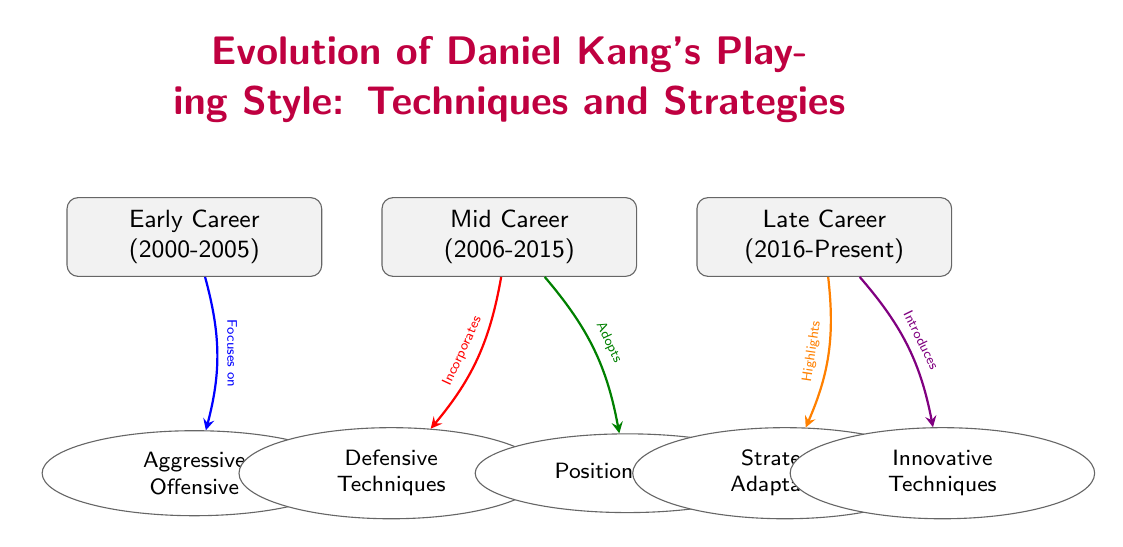What are the three career stages depicted in the diagram? The diagram lists three distinct career stages for Daniel Kang: Early Career (2000-2005), Mid Career (2006-2015), and Late Career (2016-Present). Each stage is represented by a node in the diagram as a career-type rectangle.
Answer: Early Career, Mid Career, Late Career How many techniques are highlighted in the diagram? There are five techniques or strategies represented by the ellipse nodes below the career stages: Aggressive Offensive, Defensive Techniques, Positional Play, Strategic Adaptation, and Innovative Techniques. Counting these provides the answer.
Answer: Five Which technique is associated with the Late Career stage? The Late Career stage highlights two techniques: Strategic Adaptation and Innovative Techniques. The question asks for the techniques linked to this stage, which can be found by following the arrows that connect the Late Career node to its associated techniques.
Answer: Strategic Adaptation, Innovative Techniques What technique does the Mid Career stage incorporate? The Mid Career stage is specifically connected to the Defensive Techniques through an arrow that indicates incorporation. This shows that the focus during this period includes this technique as a key part of his playing style.
Answer: Defensive Techniques Which technique is the focus of Daniel Kang's Early Career? The diagram indicates that the Early Career stage is focused on Aggressive Offensive techniques, as denoted by the arrow pointing from the Early Career node to the Aggressive Offensive technique node.
Answer: Aggressive Offensive What does the arrow color from Mid Career to Positional Play signify? The arrow from Mid Career to Positional Play is colored in green, which represents the adoption of this technique during that career stage. Thus, the color implies a relationship of taking on this technique rather than incorporating or highlighting it.
Answer: Adopts How does the Late Career technique approach differ from the Early Career? The Early Career focuses on Aggressive Offensive, while the Late Career emphasizes Strategic Adaptation and Innovative Techniques. This indicates a shift from aggressive tactics to more strategic and creative approaches as the career progresses.
Answer: Shift in focus Which color arrow represents the technique highlighted in Late Career? The arrows that indicate techniques related to Late Career are colored orange for Strategic Adaptation and violet for Innovative Techniques. Each color corresponds to a different technique emphasized in this career stage.
Answer: Orange, Violet 